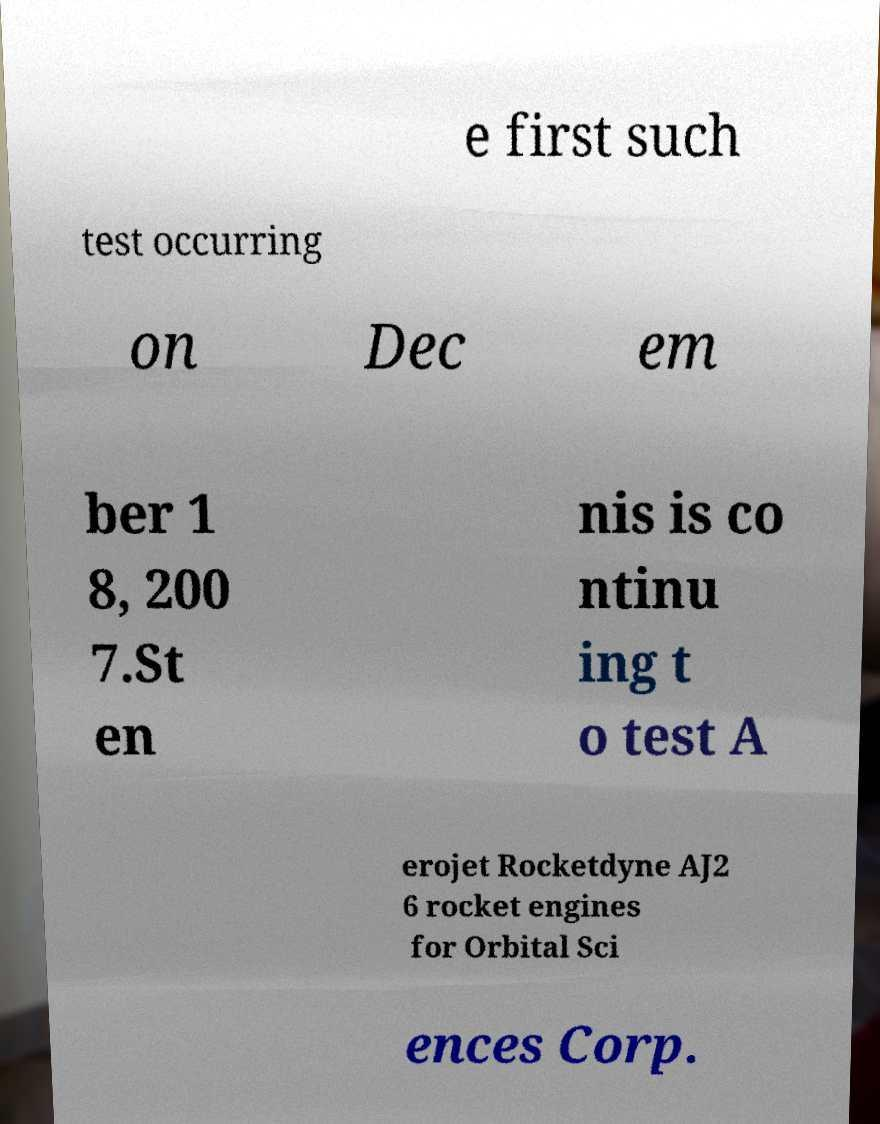What messages or text are displayed in this image? I need them in a readable, typed format. e first such test occurring on Dec em ber 1 8, 200 7.St en nis is co ntinu ing t o test A erojet Rocketdyne AJ2 6 rocket engines for Orbital Sci ences Corp. 